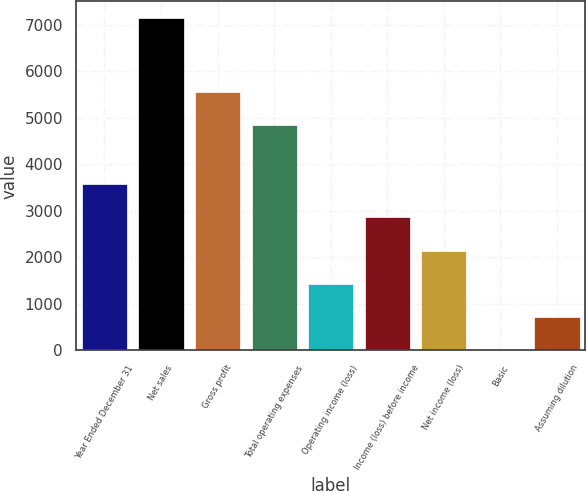<chart> <loc_0><loc_0><loc_500><loc_500><bar_chart><fcel>Year Ended December 31<fcel>Net sales<fcel>Gross profit<fcel>Total operating expenses<fcel>Operating income (loss)<fcel>Income (loss) before income<fcel>Net income (loss)<fcel>Basic<fcel>Assuming dilution<nl><fcel>3571.54<fcel>7143<fcel>5563.29<fcel>4849<fcel>1428.67<fcel>2857.25<fcel>2142.96<fcel>0.09<fcel>714.38<nl></chart> 